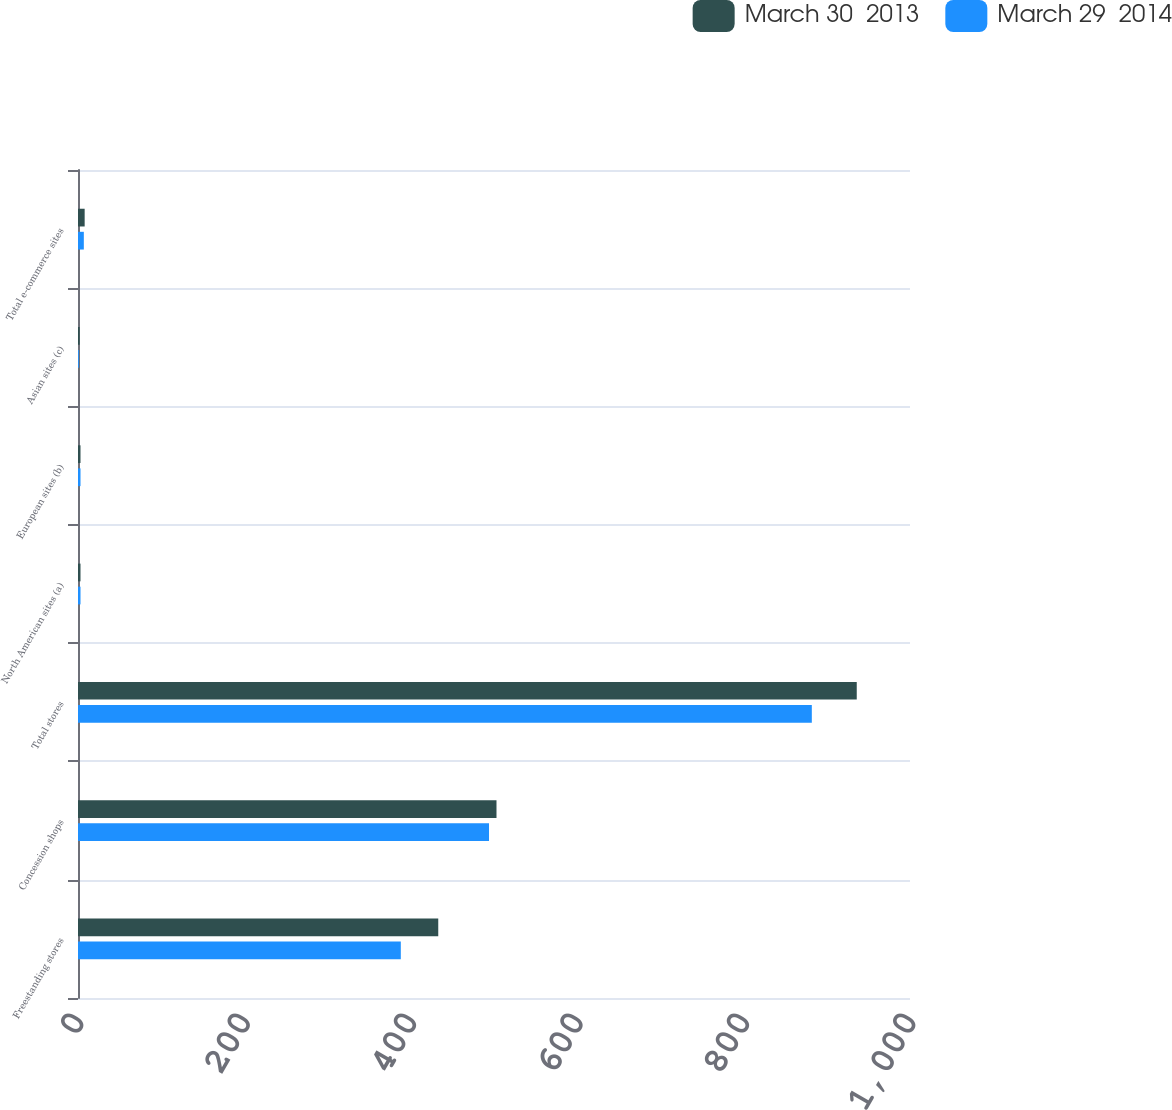Convert chart to OTSL. <chart><loc_0><loc_0><loc_500><loc_500><stacked_bar_chart><ecel><fcel>Freestanding stores<fcel>Concession shops<fcel>Total stores<fcel>North American sites (a)<fcel>European sites (b)<fcel>Asian sites (c)<fcel>Total e-commerce sites<nl><fcel>March 30  2013<fcel>433<fcel>503<fcel>936<fcel>3<fcel>3<fcel>2<fcel>8<nl><fcel>March 29  2014<fcel>388<fcel>494<fcel>882<fcel>3<fcel>3<fcel>1<fcel>7<nl></chart> 